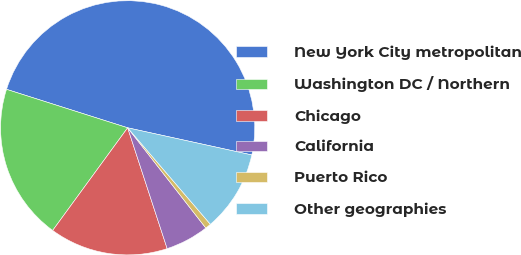Convert chart. <chart><loc_0><loc_0><loc_500><loc_500><pie_chart><fcel>New York City metropolitan<fcel>Washington DC / Northern<fcel>Chicago<fcel>California<fcel>Puerto Rico<fcel>Other geographies<nl><fcel>48.53%<fcel>19.85%<fcel>15.07%<fcel>5.51%<fcel>0.74%<fcel>10.29%<nl></chart> 